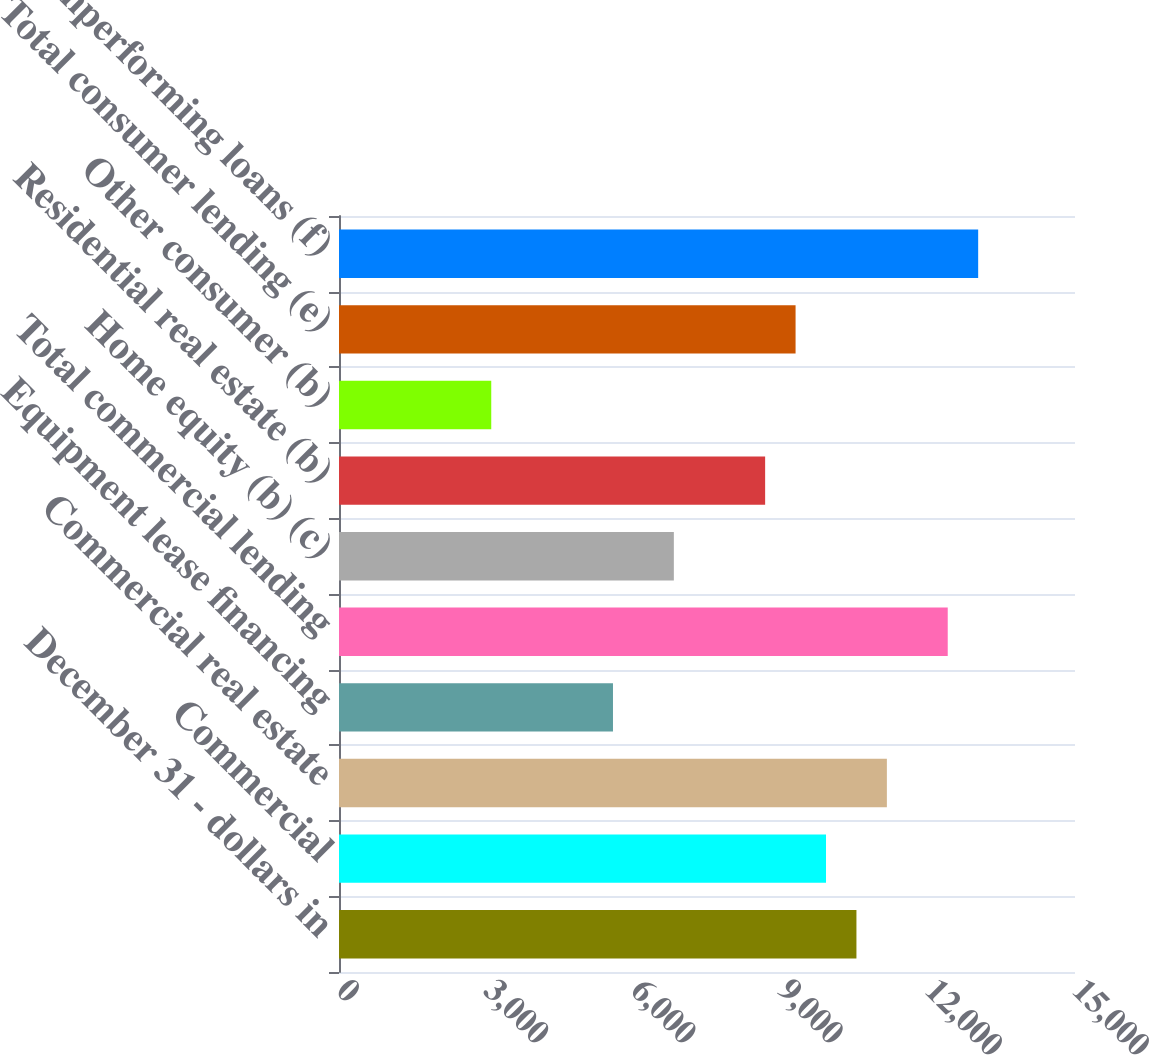Convert chart to OTSL. <chart><loc_0><loc_0><loc_500><loc_500><bar_chart><fcel>December 31 - dollars in<fcel>Commercial<fcel>Commercial real estate<fcel>Equipment lease financing<fcel>Total commercial lending<fcel>Home equity (b) (c)<fcel>Residential real estate (b)<fcel>Other consumer (b)<fcel>Total consumer lending (e)<fcel>Total nonperforming loans (f)<nl><fcel>10545.6<fcel>9925.39<fcel>11165.9<fcel>5583.78<fcel>12406.3<fcel>6824.24<fcel>8684.93<fcel>3102.86<fcel>9305.16<fcel>13026.5<nl></chart> 